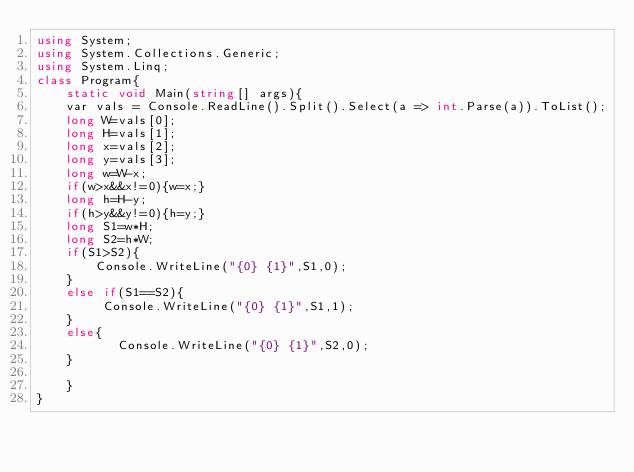<code> <loc_0><loc_0><loc_500><loc_500><_C#_>using System;
using System.Collections.Generic;
using System.Linq;
class Program{
    static void Main(string[] args){
    var vals = Console.ReadLine().Split().Select(a => int.Parse(a)).ToList();
    long W=vals[0];
    long H=vals[1];
    long x=vals[2];
    long y=vals[3];
    long w=W-x;
    if(w>x&&x!=0){w=x;}
    long h=H-y;
    if(h>y&&y!=0){h=y;}
    long S1=w*H;
    long S2=h*W;
    if(S1>S2){
        Console.WriteLine("{0} {1}",S1,0);
    }
    else if(S1==S2){
         Console.WriteLine("{0} {1}",S1,1);
    }
    else{
           Console.WriteLine("{0} {1}",S2,0);
    }
    
    }
}
</code> 